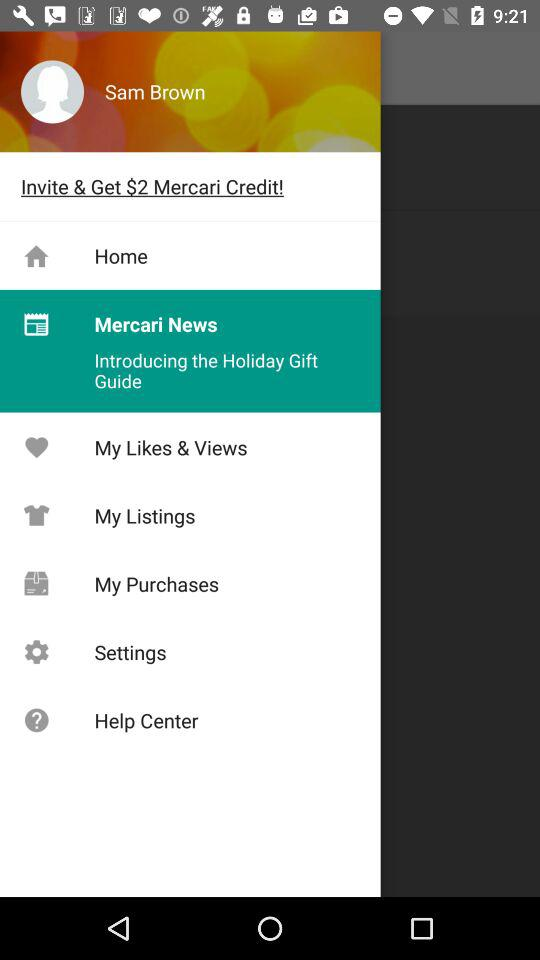What is the user name? The user name is Sam Brown. 